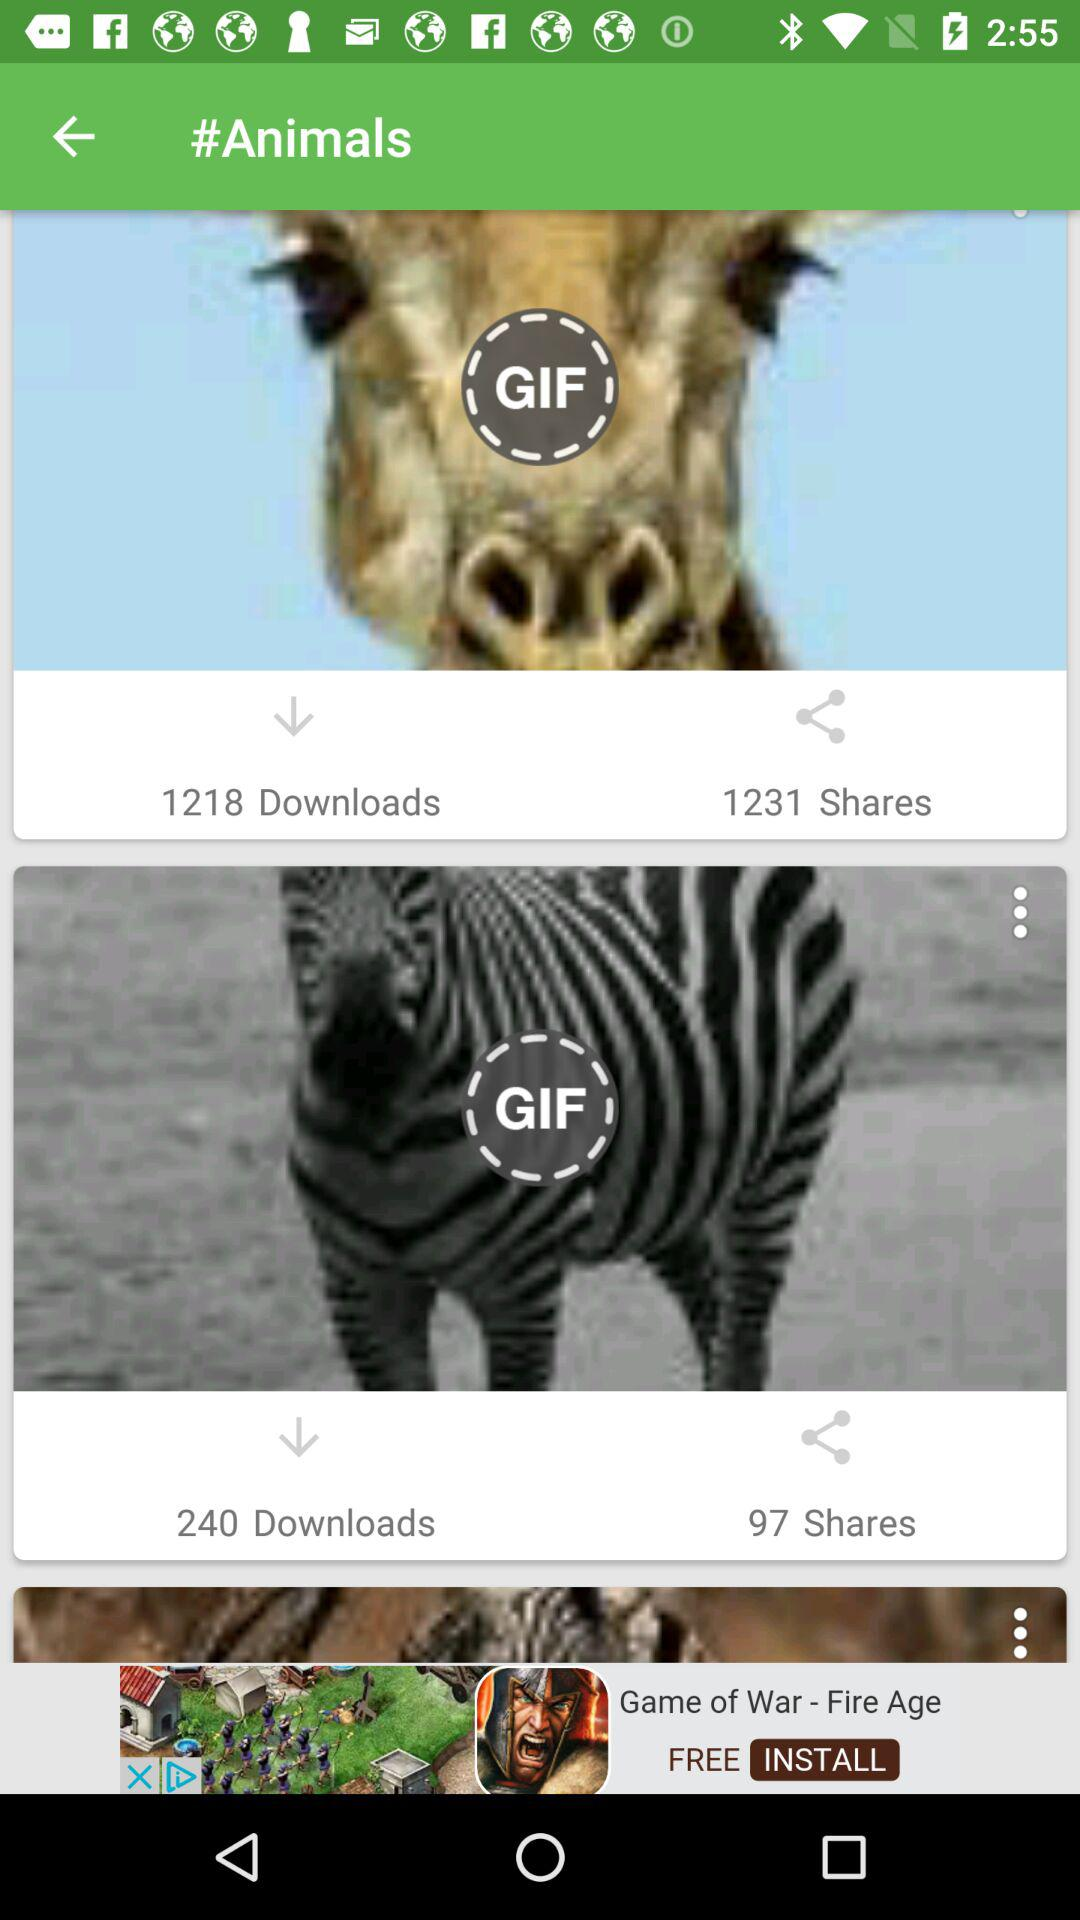What is the number of downloads for Zebra's GIF? The number of downloads for Zebra's GIF is 240. 